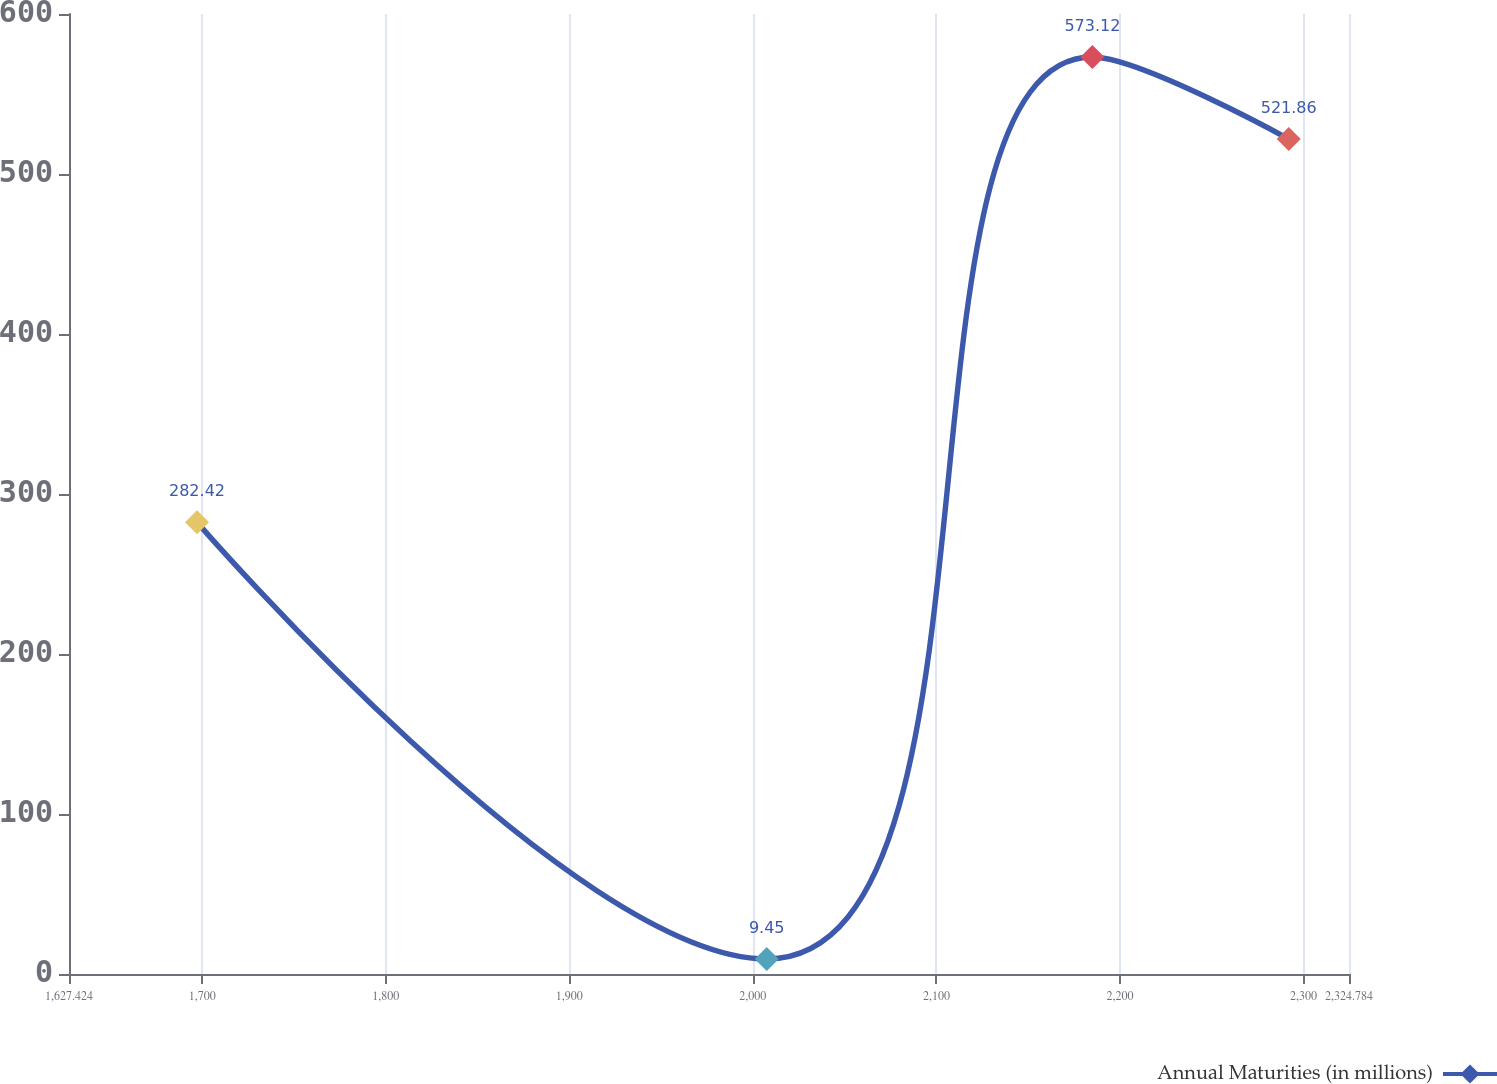Convert chart. <chart><loc_0><loc_0><loc_500><loc_500><line_chart><ecel><fcel>Annual Maturities (in millions)<nl><fcel>1697.16<fcel>282.42<nl><fcel>2007.55<fcel>9.45<nl><fcel>2184.97<fcel>573.12<nl><fcel>2291.95<fcel>521.86<nl><fcel>2394.52<fcel>451.68<nl></chart> 